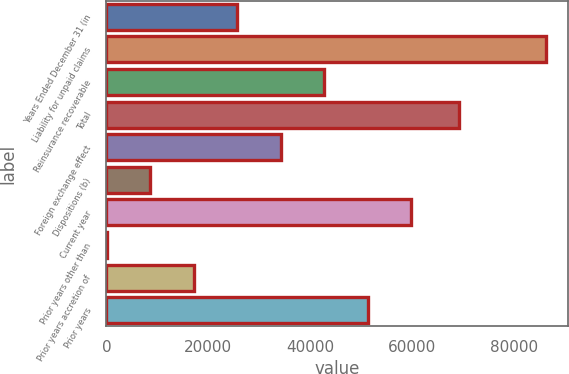Convert chart to OTSL. <chart><loc_0><loc_0><loc_500><loc_500><bar_chart><fcel>Years Ended December 31 (in<fcel>Liability for unpaid claims<fcel>Reinsurance recoverable<fcel>Total<fcel>Foreign exchange effect<fcel>Dispositions (b)<fcel>Current year<fcel>Prior years other than<fcel>Prior years accretion of<fcel>Prior years<nl><fcel>25732.6<fcel>86364.4<fcel>42809<fcel>69288<fcel>34270.8<fcel>8656.2<fcel>59885.4<fcel>118<fcel>17194.4<fcel>51347.2<nl></chart> 